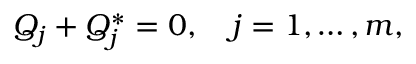<formula> <loc_0><loc_0><loc_500><loc_500>Q _ { j } + Q _ { j } ^ { * } = 0 , \quad j = 1 , \dots , m ,</formula> 